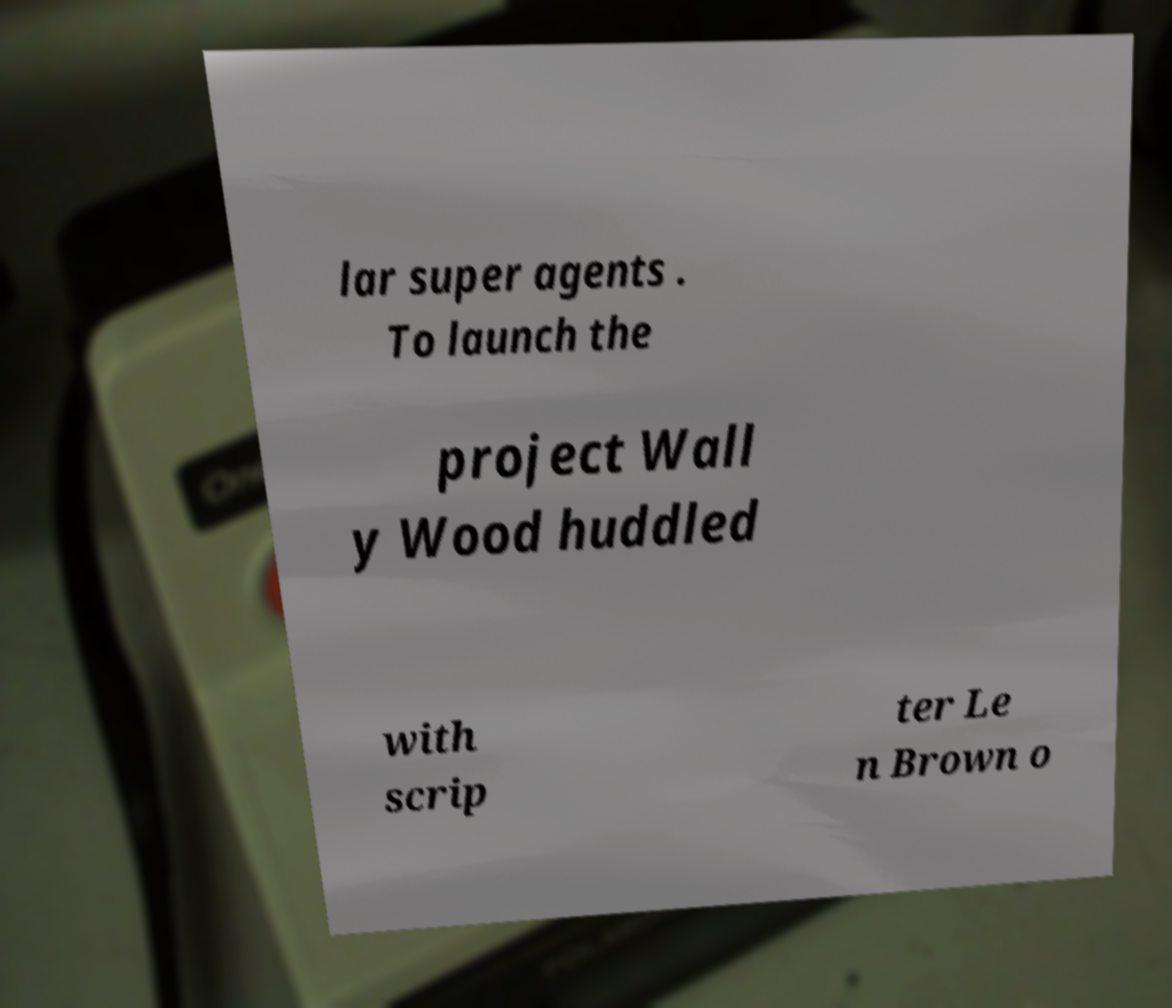For documentation purposes, I need the text within this image transcribed. Could you provide that? lar super agents . To launch the project Wall y Wood huddled with scrip ter Le n Brown o 